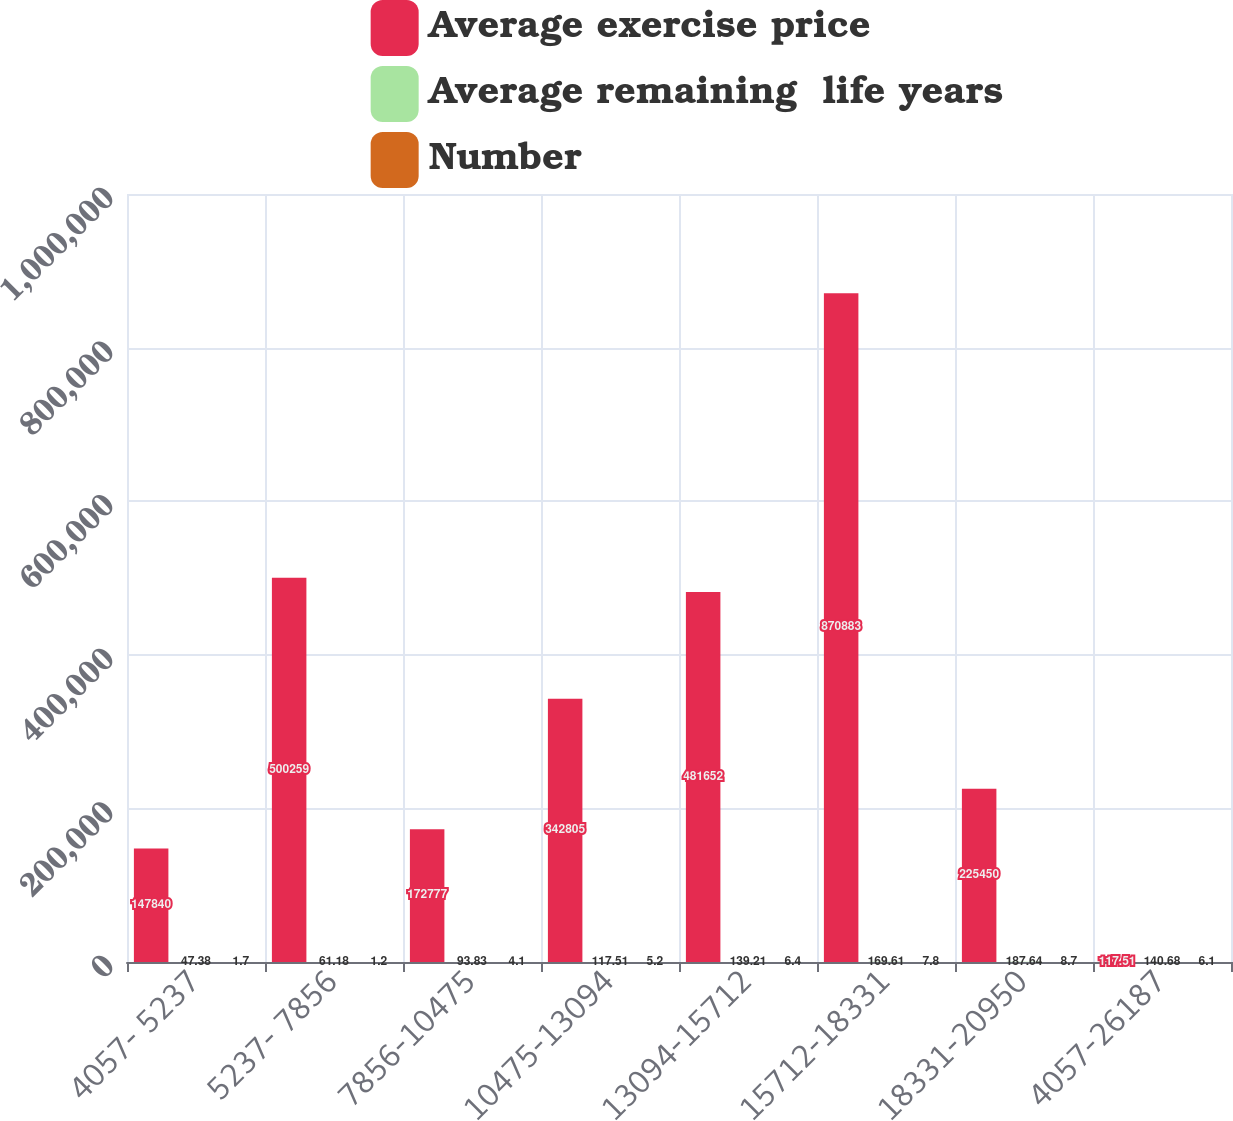Convert chart to OTSL. <chart><loc_0><loc_0><loc_500><loc_500><stacked_bar_chart><ecel><fcel>4057- 5237<fcel>5237- 7856<fcel>7856-10475<fcel>10475-13094<fcel>13094-15712<fcel>15712-18331<fcel>18331-20950<fcel>4057-26187<nl><fcel>Average exercise price<fcel>147840<fcel>500259<fcel>172777<fcel>342805<fcel>481652<fcel>870883<fcel>225450<fcel>117.51<nl><fcel>Average remaining  life years<fcel>47.38<fcel>61.18<fcel>93.83<fcel>117.51<fcel>139.21<fcel>169.61<fcel>187.64<fcel>140.68<nl><fcel>Number<fcel>1.7<fcel>1.2<fcel>4.1<fcel>5.2<fcel>6.4<fcel>7.8<fcel>8.7<fcel>6.1<nl></chart> 